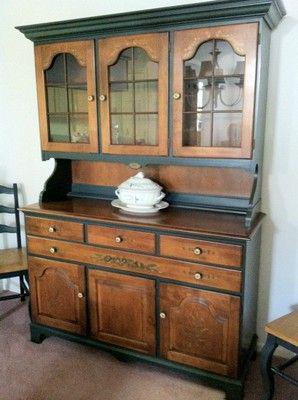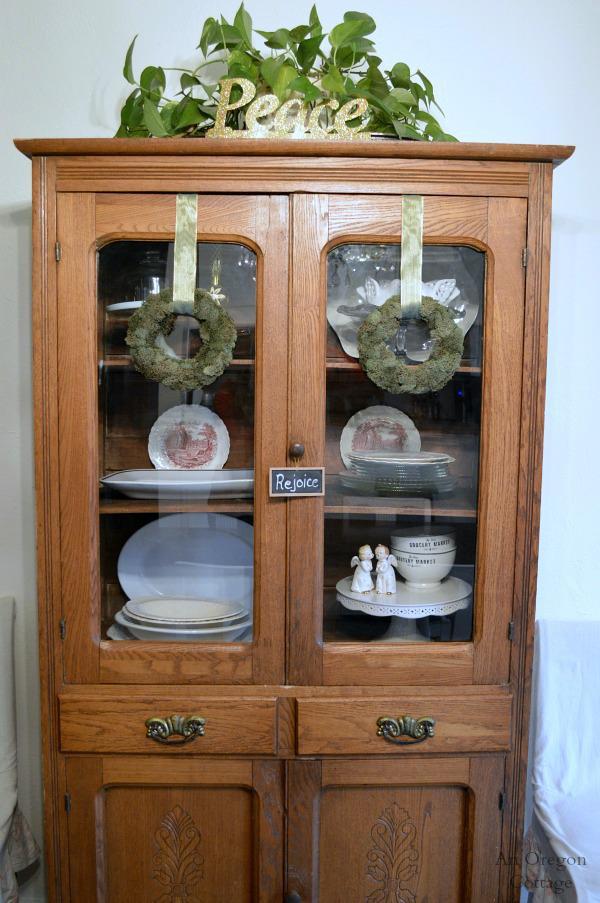The first image is the image on the left, the second image is the image on the right. Analyze the images presented: Is the assertion "All china cabinets have solid doors and drawers at the bottom and glass fronted doors on top." valid? Answer yes or no. Yes. The first image is the image on the left, the second image is the image on the right. Given the left and right images, does the statement "There is a plant resting on top of one of the furniture." hold true? Answer yes or no. Yes. 